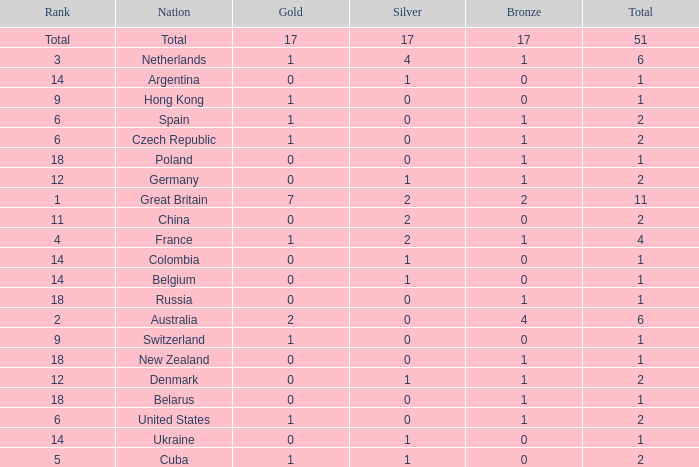Tell me the lowest gold for rank of 6 and total less than 2 None. 